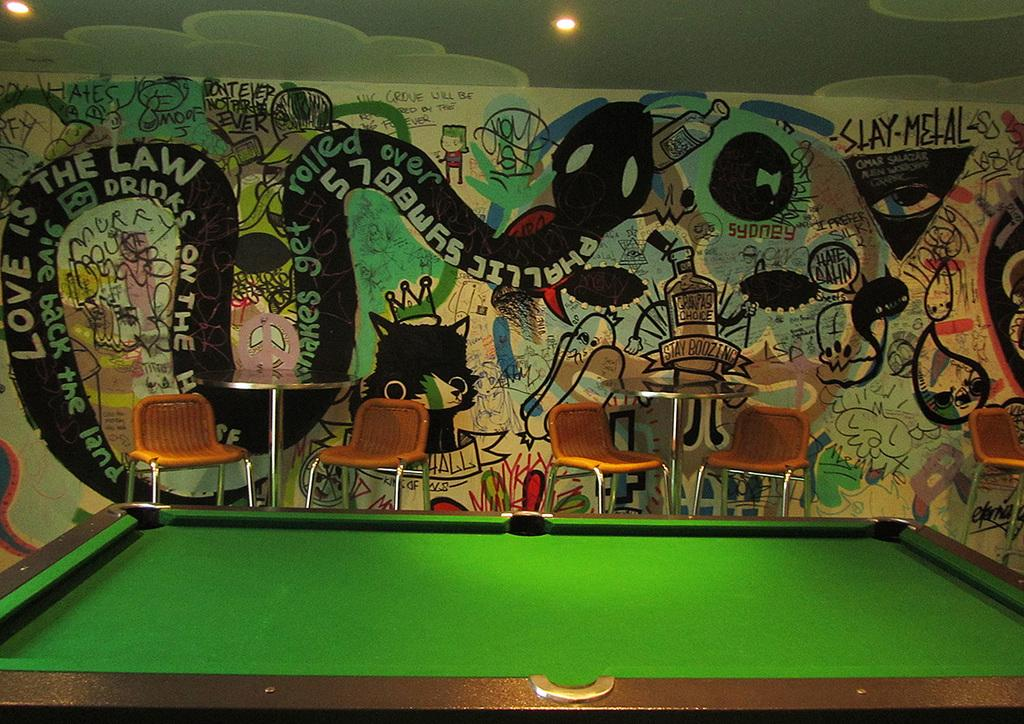What type of furniture is located in the center of the image? There are tables and chairs in the center of the image. Can you describe the positioning of the table in the image? There is a table in the front bottom of the image. What can be seen in the background of the image? There is a wall visible in the background of the image. How many lamps are on the table in the image? There is no lamp present on the table in the image. What type of footwear is visible on the people in the image? There is no footwear visible in the image, as it only shows tables, chairs, and a wall. 